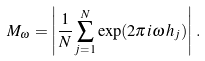Convert formula to latex. <formula><loc_0><loc_0><loc_500><loc_500>M _ { \omega } = \left | \frac { 1 } { N } \sum _ { j = 1 } ^ { N } \exp ( 2 \pi i \omega \, h _ { j } ) \right | \, .</formula> 